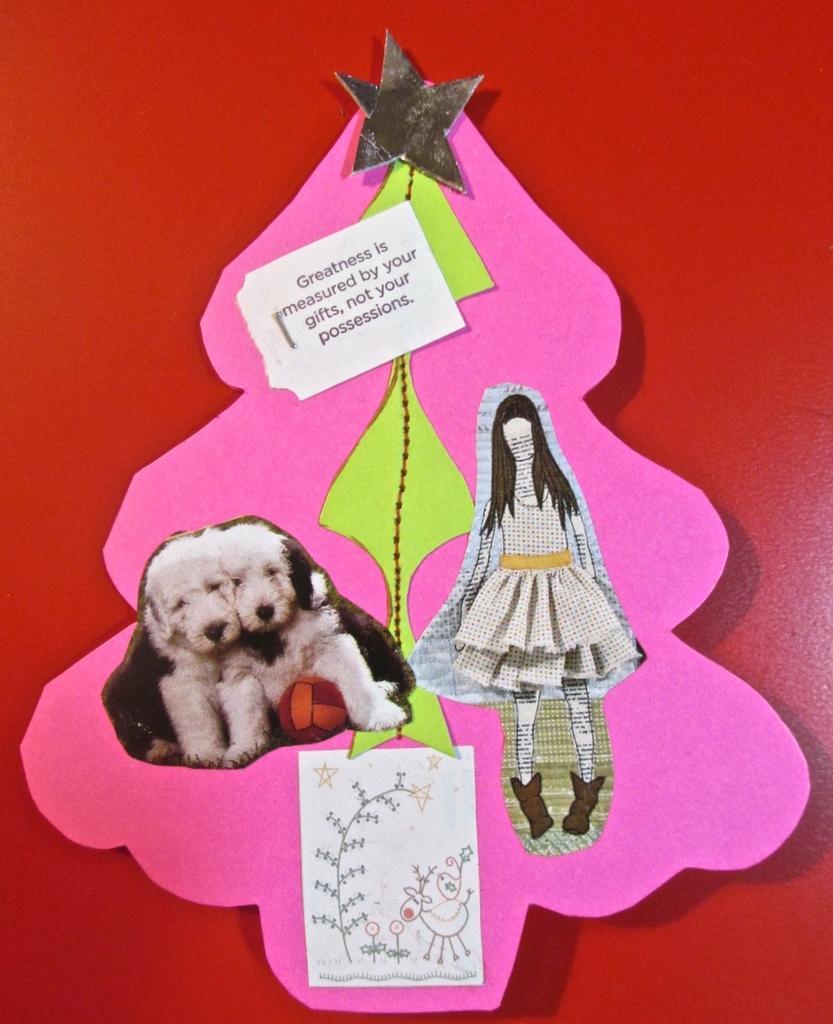Describe this image in one or two sentences. In this image I can see two dogs. They are in white and black color. I can see a red ball and white dress. I can see two papers are attached to the pink board. Pink board is attached to the red color board. 